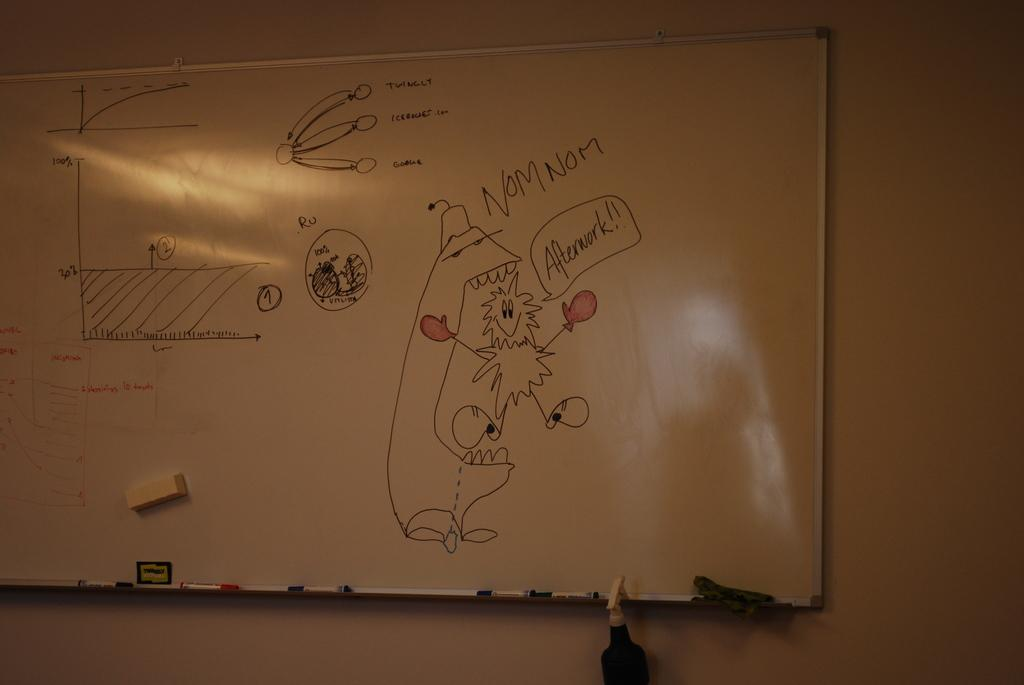<image>
Offer a succinct explanation of the picture presented. Whiteboard showing a cartoon drawing and the words Nom Nom. 